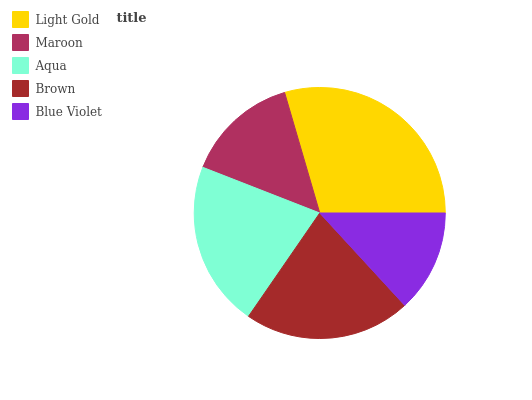Is Blue Violet the minimum?
Answer yes or no. Yes. Is Light Gold the maximum?
Answer yes or no. Yes. Is Maroon the minimum?
Answer yes or no. No. Is Maroon the maximum?
Answer yes or no. No. Is Light Gold greater than Maroon?
Answer yes or no. Yes. Is Maroon less than Light Gold?
Answer yes or no. Yes. Is Maroon greater than Light Gold?
Answer yes or no. No. Is Light Gold less than Maroon?
Answer yes or no. No. Is Aqua the high median?
Answer yes or no. Yes. Is Aqua the low median?
Answer yes or no. Yes. Is Blue Violet the high median?
Answer yes or no. No. Is Maroon the low median?
Answer yes or no. No. 